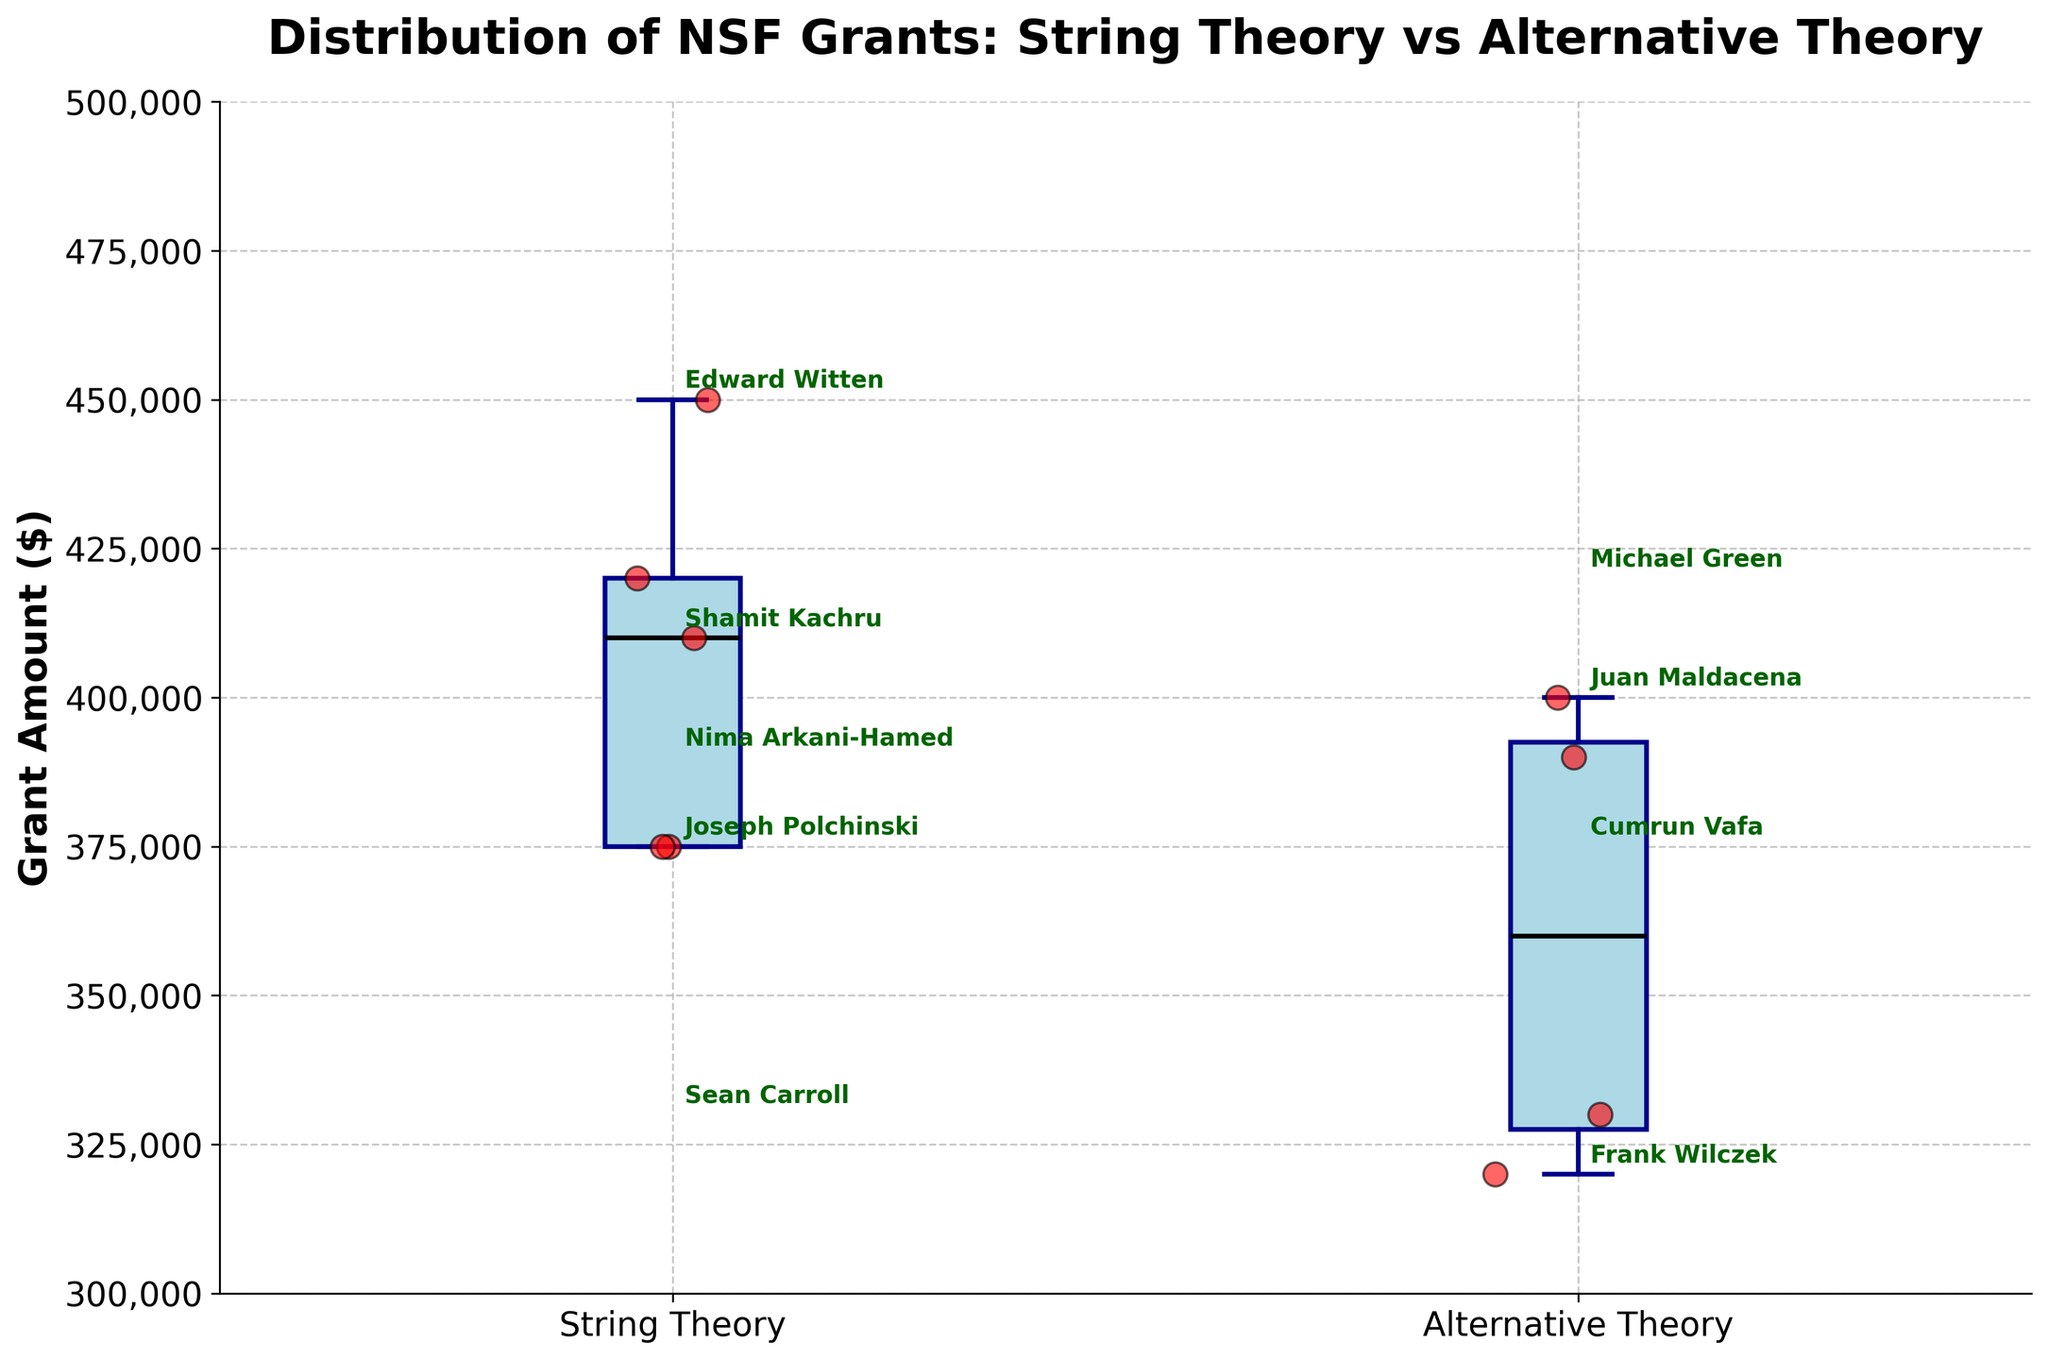How many box plots are shown in the figure? The figure displays a comparison between two groups, thus containing two box plots: one for String Theory and one for Alternative Theory.
Answer: 2 What is the title of the figure? The title summarizes the content of the figure, which is the "Distribution of NSF Grants: String Theory vs Alternative Theory".
Answer: Distribution of NSF Grants: String Theory vs Alternative Theory Which group has the higher median grant amount? Look at the black median line inside the box plot for both groups: the String Theory box has a higher median line compared to the Alternative Theory box.
Answer: String Theory What's the range of grant amounts for the Alternative Theory group? The range can be determined by the whiskers of the box plot for Alternative Theory. The lower whisker is at $320,000, and the upper whisker is at $400,000, giving us a range of $400,000 - $320,000.
Answer: $80,000 How many researchers received grants in the String Theory group? Count the number of scatter points (red dots) over the String Theory box plot. There are 5 red dots hovering over the String Theory box plot.
Answer: 5 Which researcher received the lowest grant amount, and what was that amount? Identify the lowest scatter point on the plot. It is labeled "Frank Wilczek" in the Alternative Theory group. The scatter plot shows this amount around $320,000.
Answer: Frank Wilczek, $320,000 What is the interquartile range (IQR) for the String Theory group? The IQR is the length of the box in the box plot and represents the middle 50% of the data. For String Theory, this ranges from around $375,000 to $425,000.
Answer: $50,000 Which group shows greater variability in grant amounts? Variability is denoted by the spread of the box and whiskers in the box plot. The String Theory group shows a larger spread compared to the Alternative Theory group, indicating greater variability.
Answer: String Theory If there's an outlier in the String Theory data, who is the researcher, and what is the grant amount? Outliers would be shown as points lying outside the whiskers. There are no outliers in the String Theory group based on the points shown within the whiskers.
Answer: None Do any researchers have the same grant amount? Check if any scatter points align horizontally. The grant amounts for Cumrun Vafa and Joseph Polchinski in the String Theory group both appear to be $375,000.
Answer: Yes, Cumrun Vafa and Joseph Polchinski 